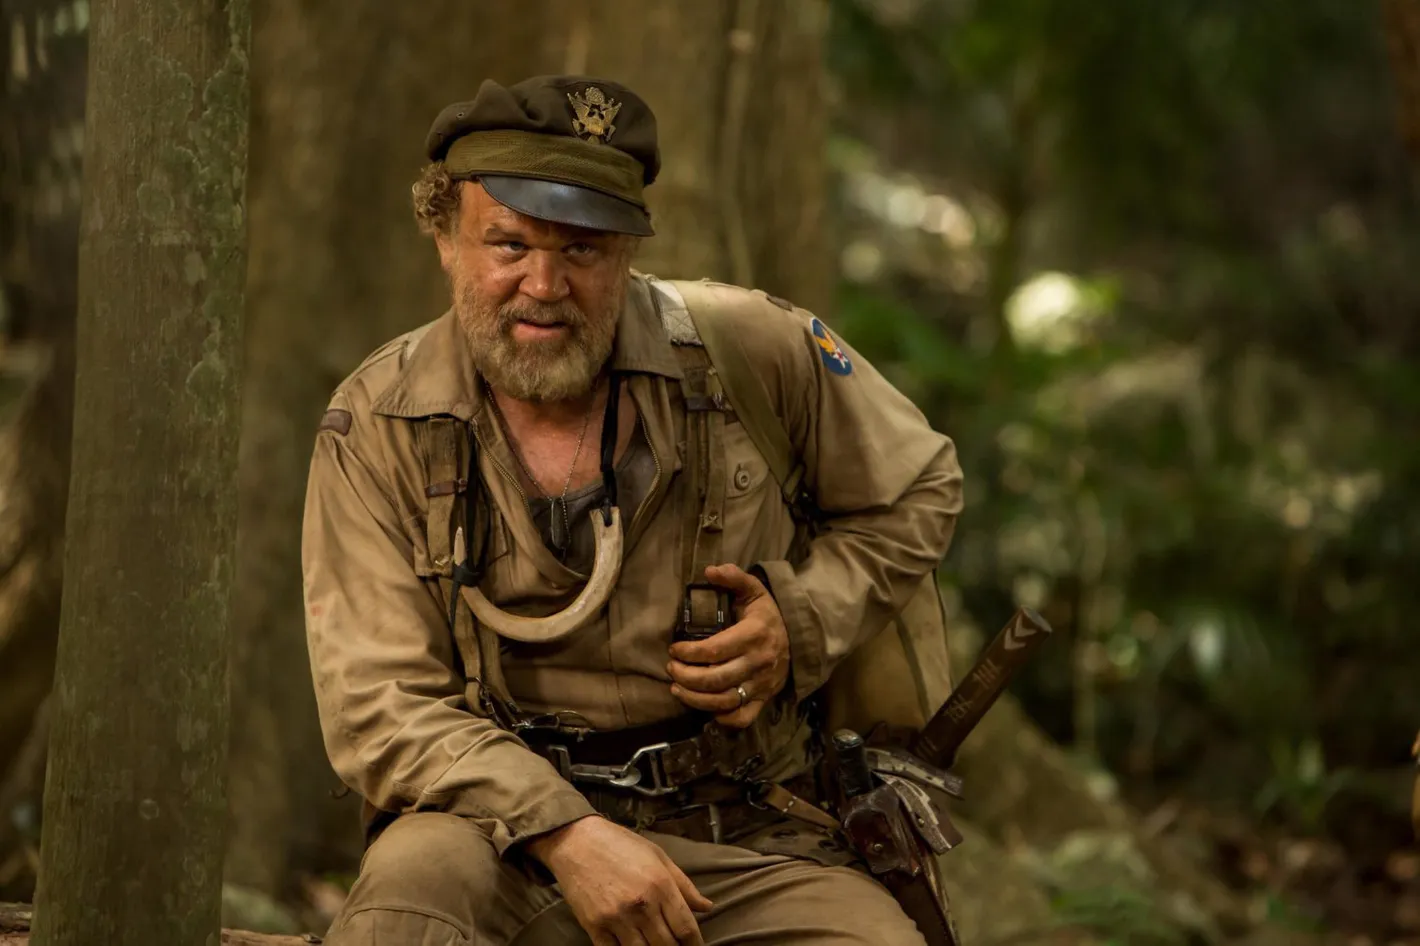Can you craft a creative backstory for the soldier? This soldier, named Captain Elias Creed, once a history professor at a prestigious university, found himself drawn into military service after a profound personal loss. He trades his academic gown for the uniform of an officer when the war claims the life of his younger brother. Driven by a mix of duty, vengeance, and a hope to protect others from experiencing similar pain, Captain Creed immerses himself in the military life. His intimate knowledge of ancient battle strategies and terrain navigation aids him greatly in modern warfare, turning him into a valuable asset for reconnaissance missions. The dense forest in the image is reminiscent of his childhood adventures, a terrain he's both familiar with and deeply respectful of. As he sits on that tree stump, perhaps he’s also grappling with memories of his erstwhile peaceful life, using them to fuel his resolve in the face of adversity. Imagine the most fantastical scenario involving this soldier. What might it look like? In the heart of this forest, Captain Elias Creed stumbles upon an ancient, mystical portal hidden beneath the roots of a colossal tree. The portal, shimmering with an otherworldly light, beckons him with whispers of a realm long forgotten. Deciding to cross the threshold, he steps into a surreal landscape where time flows differently and the very fabric of reality bends. Here, mythical creatures roam, and the skies are painted with colors unseen in the natural world. Captain Creed becomes entangled in an age-old conflict between benevolent sages and dark entities threatening the balance of this mystical realm. Using his modern military skills and newfound arcane knowledge, he takes on the role of a guardian, leading a coalition of fantastical beings in an epic battle to restore harmony to this enchanted world. His uniform morphs with the magic of the realm, blending medieval armor with modern tactical gear, symbolizing his unique position as a bridge between worlds. 